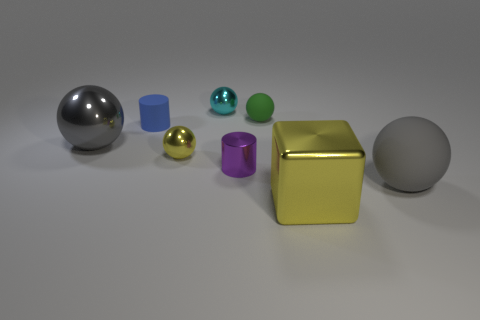Subtract all green cylinders. Subtract all yellow balls. How many cylinders are left? 2 Subtract all blue balls. How many brown blocks are left? 0 Add 4 small things. How many purples exist? 0 Subtract all brown balls. Subtract all small cyan metal objects. How many objects are left? 7 Add 5 tiny shiny cylinders. How many tiny shiny cylinders are left? 6 Add 3 gray matte spheres. How many gray matte spheres exist? 4 Add 1 rubber things. How many objects exist? 9 Subtract all blue cylinders. How many cylinders are left? 1 Subtract all tiny cyan metal spheres. How many spheres are left? 4 Subtract 0 red cubes. How many objects are left? 8 